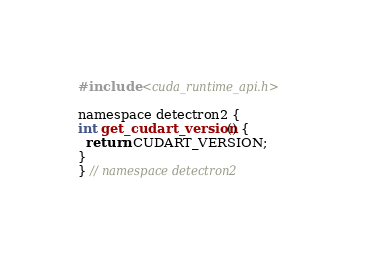Convert code to text. <code><loc_0><loc_0><loc_500><loc_500><_Cuda_>#include <cuda_runtime_api.h>

namespace detectron2 {
int get_cudart_version() {
  return CUDART_VERSION;
}
} // namespace detectron2
</code> 